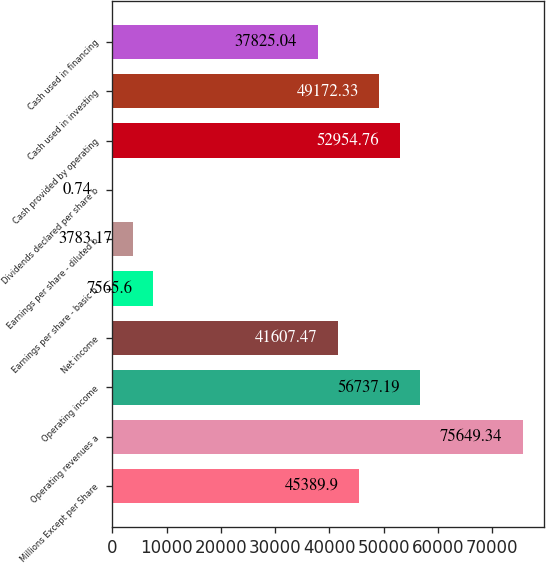Convert chart. <chart><loc_0><loc_0><loc_500><loc_500><bar_chart><fcel>Millions Except per Share<fcel>Operating revenues a<fcel>Operating income<fcel>Net income<fcel>Earnings per share - basic b<fcel>Earnings per share - diluted b<fcel>Dividends declared per share b<fcel>Cash provided by operating<fcel>Cash used in investing<fcel>Cash used in financing<nl><fcel>45389.9<fcel>75649.3<fcel>56737.2<fcel>41607.5<fcel>7565.6<fcel>3783.17<fcel>0.74<fcel>52954.8<fcel>49172.3<fcel>37825<nl></chart> 